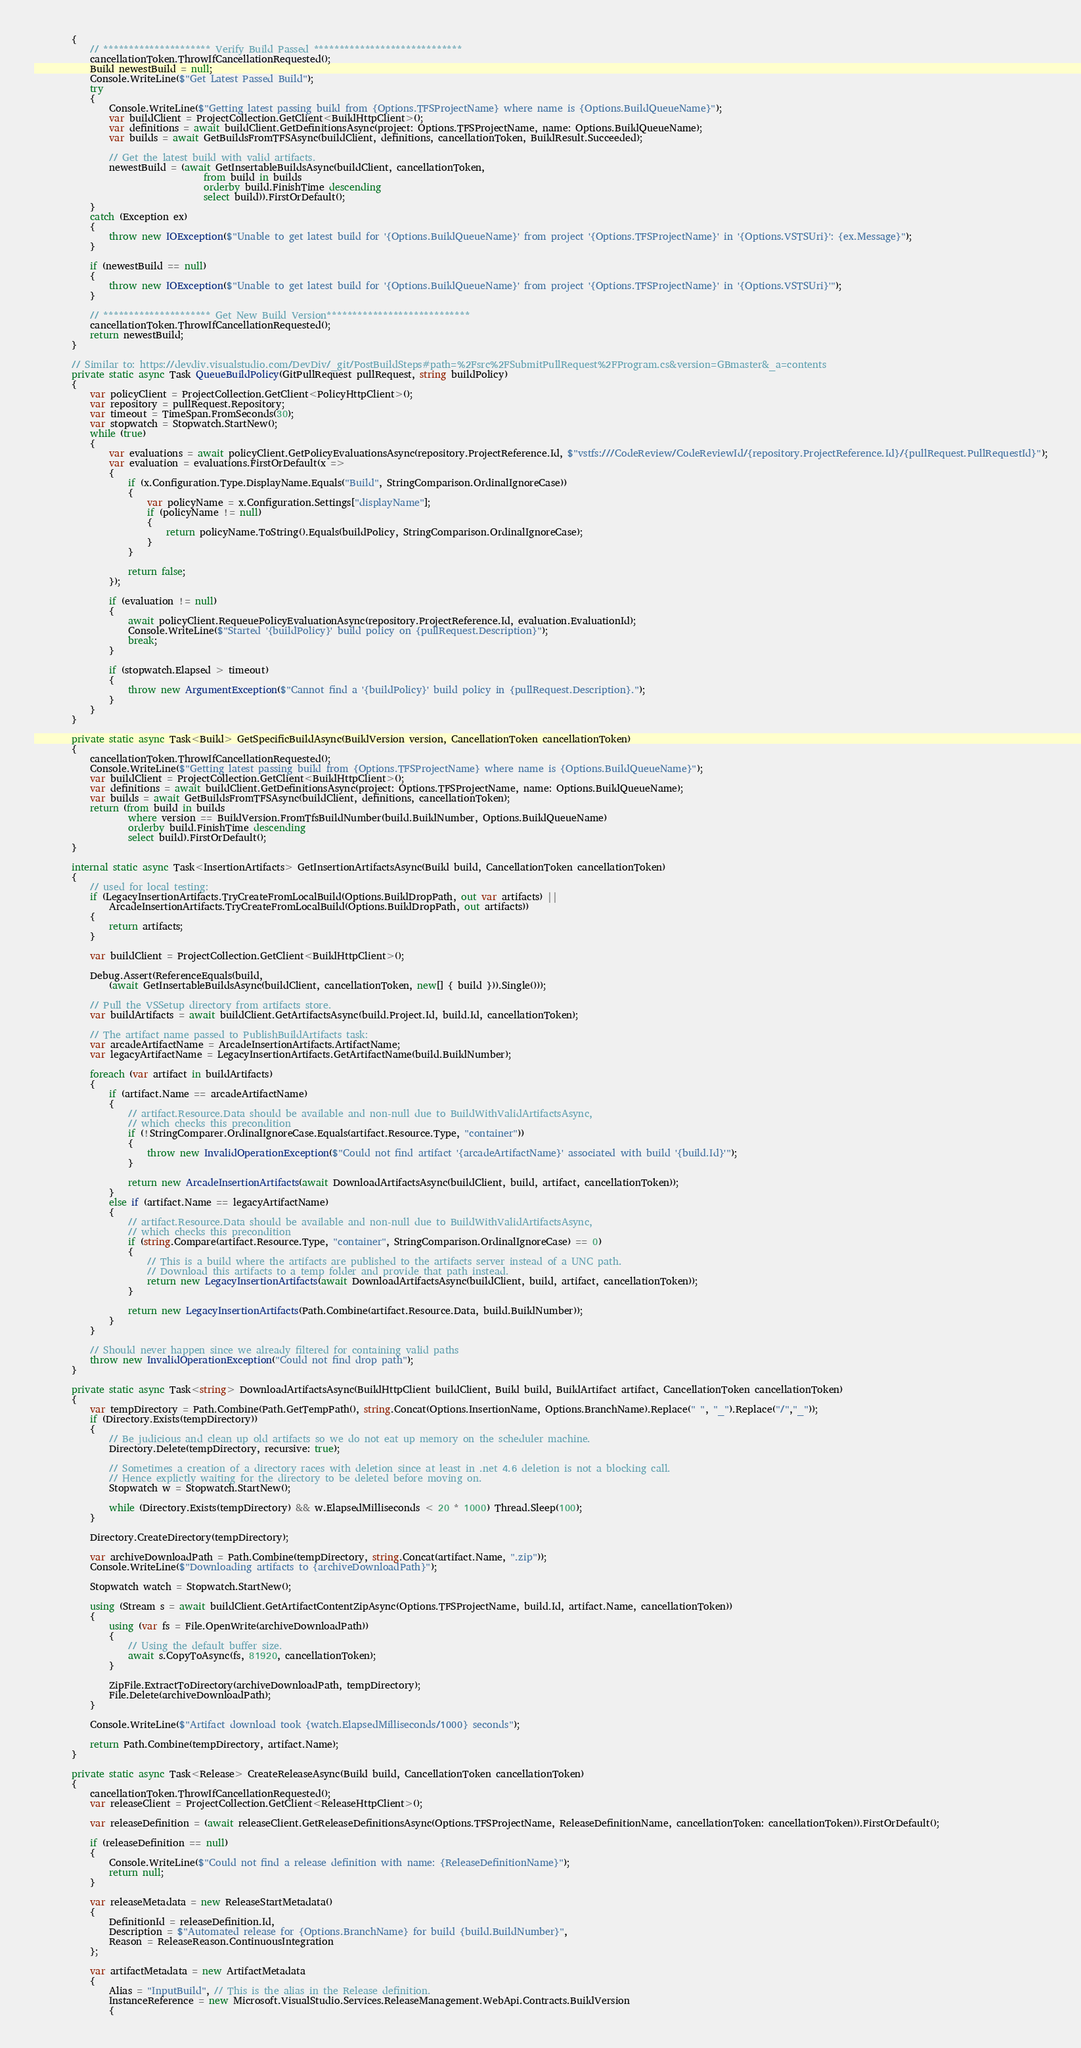<code> <loc_0><loc_0><loc_500><loc_500><_C#_>        {
            // ********************* Verify Build Passed *****************************
            cancellationToken.ThrowIfCancellationRequested();
            Build newestBuild = null;
            Console.WriteLine($"Get Latest Passed Build");
            try
            {
                Console.WriteLine($"Getting latest passing build from {Options.TFSProjectName} where name is {Options.BuildQueueName}");
                var buildClient = ProjectCollection.GetClient<BuildHttpClient>();
                var definitions = await buildClient.GetDefinitionsAsync(project: Options.TFSProjectName, name: Options.BuildQueueName);
                var builds = await GetBuildsFromTFSAsync(buildClient, definitions, cancellationToken, BuildResult.Succeeded);

                // Get the latest build with valid artifacts.
                newestBuild = (await GetInsertableBuildsAsync(buildClient, cancellationToken,
                                    from build in builds
                                    orderby build.FinishTime descending
                                    select build)).FirstOrDefault();
            }
            catch (Exception ex)
            {
                throw new IOException($"Unable to get latest build for '{Options.BuildQueueName}' from project '{Options.TFSProjectName}' in '{Options.VSTSUri}': {ex.Message}");
            }

            if (newestBuild == null)
            {
                throw new IOException($"Unable to get latest build for '{Options.BuildQueueName}' from project '{Options.TFSProjectName}' in '{Options.VSTSUri}'");
            }

            // ********************* Get New Build Version****************************
            cancellationToken.ThrowIfCancellationRequested();
            return newestBuild;
        }

        // Similar to: https://devdiv.visualstudio.com/DevDiv/_git/PostBuildSteps#path=%2Fsrc%2FSubmitPullRequest%2FProgram.cs&version=GBmaster&_a=contents
        private static async Task QueueBuildPolicy(GitPullRequest pullRequest, string buildPolicy)
        {
            var policyClient = ProjectCollection.GetClient<PolicyHttpClient>();
            var repository = pullRequest.Repository;
            var timeout = TimeSpan.FromSeconds(30);
            var stopwatch = Stopwatch.StartNew();
            while (true)
            {
                var evaluations = await policyClient.GetPolicyEvaluationsAsync(repository.ProjectReference.Id, $"vstfs:///CodeReview/CodeReviewId/{repository.ProjectReference.Id}/{pullRequest.PullRequestId}");
                var evaluation = evaluations.FirstOrDefault(x =>
                {
                    if (x.Configuration.Type.DisplayName.Equals("Build", StringComparison.OrdinalIgnoreCase))
                    {
                        var policyName = x.Configuration.Settings["displayName"];
                        if (policyName != null)
                        {
                            return policyName.ToString().Equals(buildPolicy, StringComparison.OrdinalIgnoreCase);
                        }
                    }

                    return false;
                });

                if (evaluation != null)
                {
                    await policyClient.RequeuePolicyEvaluationAsync(repository.ProjectReference.Id, evaluation.EvaluationId);
                    Console.WriteLine($"Started '{buildPolicy}' build policy on {pullRequest.Description}");
                    break;
                }

                if (stopwatch.Elapsed > timeout)
                {
                    throw new ArgumentException($"Cannot find a '{buildPolicy}' build policy in {pullRequest.Description}.");
                }
            }
        }

        private static async Task<Build> GetSpecificBuildAsync(BuildVersion version, CancellationToken cancellationToken)
        {
            cancellationToken.ThrowIfCancellationRequested();
            Console.WriteLine($"Getting latest passing build from {Options.TFSProjectName} where name is {Options.BuildQueueName}");
            var buildClient = ProjectCollection.GetClient<BuildHttpClient>();
            var definitions = await buildClient.GetDefinitionsAsync(project: Options.TFSProjectName, name: Options.BuildQueueName);
            var builds = await GetBuildsFromTFSAsync(buildClient, definitions, cancellationToken);
            return (from build in builds
                    where version == BuildVersion.FromTfsBuildNumber(build.BuildNumber, Options.BuildQueueName)
                    orderby build.FinishTime descending
                    select build).FirstOrDefault();
        }

        internal static async Task<InsertionArtifacts> GetInsertionArtifactsAsync(Build build, CancellationToken cancellationToken)
        {
            // used for local testing:
            if (LegacyInsertionArtifacts.TryCreateFromLocalBuild(Options.BuildDropPath, out var artifacts) ||
                ArcadeInsertionArtifacts.TryCreateFromLocalBuild(Options.BuildDropPath, out artifacts))
            {
                return artifacts;
            }

            var buildClient = ProjectCollection.GetClient<BuildHttpClient>();

            Debug.Assert(ReferenceEquals(build,
                (await GetInsertableBuildsAsync(buildClient, cancellationToken, new[] { build })).Single()));

            // Pull the VSSetup directory from artifacts store.
            var buildArtifacts = await buildClient.GetArtifactsAsync(build.Project.Id, build.Id, cancellationToken);

            // The artifact name passed to PublishBuildArtifacts task:
            var arcadeArtifactName = ArcadeInsertionArtifacts.ArtifactName;
            var legacyArtifactName = LegacyInsertionArtifacts.GetArtifactName(build.BuildNumber);

            foreach (var artifact in buildArtifacts)
            {
                if (artifact.Name == arcadeArtifactName)
                {
                    // artifact.Resource.Data should be available and non-null due to BuildWithValidArtifactsAsync,
                    // which checks this precondition
                    if (!StringComparer.OrdinalIgnoreCase.Equals(artifact.Resource.Type, "container"))
                    {
                        throw new InvalidOperationException($"Could not find artifact '{arcadeArtifactName}' associated with build '{build.Id}'");
                    }

                    return new ArcadeInsertionArtifacts(await DownloadArtifactsAsync(buildClient, build, artifact, cancellationToken));
                }
                else if (artifact.Name == legacyArtifactName)
                {
                    // artifact.Resource.Data should be available and non-null due to BuildWithValidArtifactsAsync,
                    // which checks this precondition
                    if (string.Compare(artifact.Resource.Type, "container", StringComparison.OrdinalIgnoreCase) == 0)
                    {
                        // This is a build where the artifacts are published to the artifacts server instead of a UNC path.
                        // Download this artifacts to a temp folder and provide that path instead.
                        return new LegacyInsertionArtifacts(await DownloadArtifactsAsync(buildClient, build, artifact, cancellationToken));
                    }

                    return new LegacyInsertionArtifacts(Path.Combine(artifact.Resource.Data, build.BuildNumber));
                }
            }

            // Should never happen since we already filtered for containing valid paths
            throw new InvalidOperationException("Could not find drop path");
        }

        private static async Task<string> DownloadArtifactsAsync(BuildHttpClient buildClient, Build build, BuildArtifact artifact, CancellationToken cancellationToken)
        {
            var tempDirectory = Path.Combine(Path.GetTempPath(), string.Concat(Options.InsertionName, Options.BranchName).Replace(" ", "_").Replace("/","_"));
            if (Directory.Exists(tempDirectory))
            {
                // Be judicious and clean up old artifacts so we do not eat up memory on the scheduler machine.
                Directory.Delete(tempDirectory, recursive: true);

                // Sometimes a creation of a directory races with deletion since at least in .net 4.6 deletion is not a blocking call.
                // Hence explictly waiting for the directory to be deleted before moving on.
                Stopwatch w = Stopwatch.StartNew();

                while (Directory.Exists(tempDirectory) && w.ElapsedMilliseconds < 20 * 1000) Thread.Sleep(100);
            }

            Directory.CreateDirectory(tempDirectory);

            var archiveDownloadPath = Path.Combine(tempDirectory, string.Concat(artifact.Name, ".zip"));
            Console.WriteLine($"Downloading artifacts to {archiveDownloadPath}");

            Stopwatch watch = Stopwatch.StartNew();

            using (Stream s = await buildClient.GetArtifactContentZipAsync(Options.TFSProjectName, build.Id, artifact.Name, cancellationToken))
            {
                using (var fs = File.OpenWrite(archiveDownloadPath))
                {
                    // Using the default buffer size.
                    await s.CopyToAsync(fs, 81920, cancellationToken);
                }

                ZipFile.ExtractToDirectory(archiveDownloadPath, tempDirectory);
                File.Delete(archiveDownloadPath);
            }

            Console.WriteLine($"Artifact download took {watch.ElapsedMilliseconds/1000} seconds");

            return Path.Combine(tempDirectory, artifact.Name);
        }

        private static async Task<Release> CreateReleaseAsync(Build build, CancellationToken cancellationToken)
        {
            cancellationToken.ThrowIfCancellationRequested();
            var releaseClient = ProjectCollection.GetClient<ReleaseHttpClient>();

            var releaseDefinition = (await releaseClient.GetReleaseDefinitionsAsync(Options.TFSProjectName, ReleaseDefinitionName, cancellationToken: cancellationToken)).FirstOrDefault();

            if (releaseDefinition == null)
            {
                Console.WriteLine($"Could not find a release definition with name: {ReleaseDefinitionName}");
                return null;
            }

            var releaseMetadata = new ReleaseStartMetadata()
            {
                DefinitionId = releaseDefinition.Id,
                Description = $"Automated release for {Options.BranchName} for build {build.BuildNumber}",
                Reason = ReleaseReason.ContinuousIntegration
            };

            var artifactMetadata = new ArtifactMetadata
            {
                Alias = "InputBuild", // This is the alias in the Release definition.
                InstanceReference = new Microsoft.VisualStudio.Services.ReleaseManagement.WebApi.Contracts.BuildVersion
                {</code> 